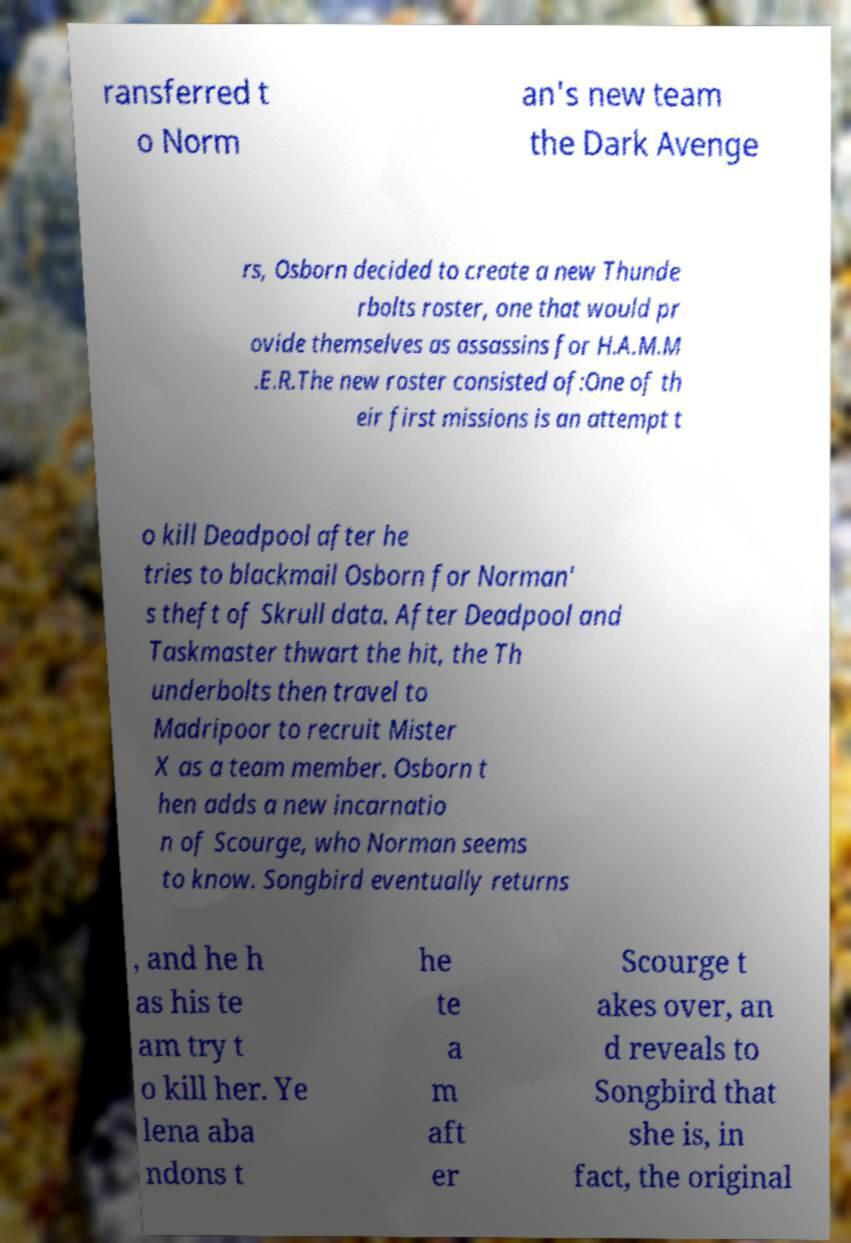Can you accurately transcribe the text from the provided image for me? ransferred t o Norm an's new team the Dark Avenge rs, Osborn decided to create a new Thunde rbolts roster, one that would pr ovide themselves as assassins for H.A.M.M .E.R.The new roster consisted of:One of th eir first missions is an attempt t o kill Deadpool after he tries to blackmail Osborn for Norman' s theft of Skrull data. After Deadpool and Taskmaster thwart the hit, the Th underbolts then travel to Madripoor to recruit Mister X as a team member. Osborn t hen adds a new incarnatio n of Scourge, who Norman seems to know. Songbird eventually returns , and he h as his te am try t o kill her. Ye lena aba ndons t he te a m aft er Scourge t akes over, an d reveals to Songbird that she is, in fact, the original 